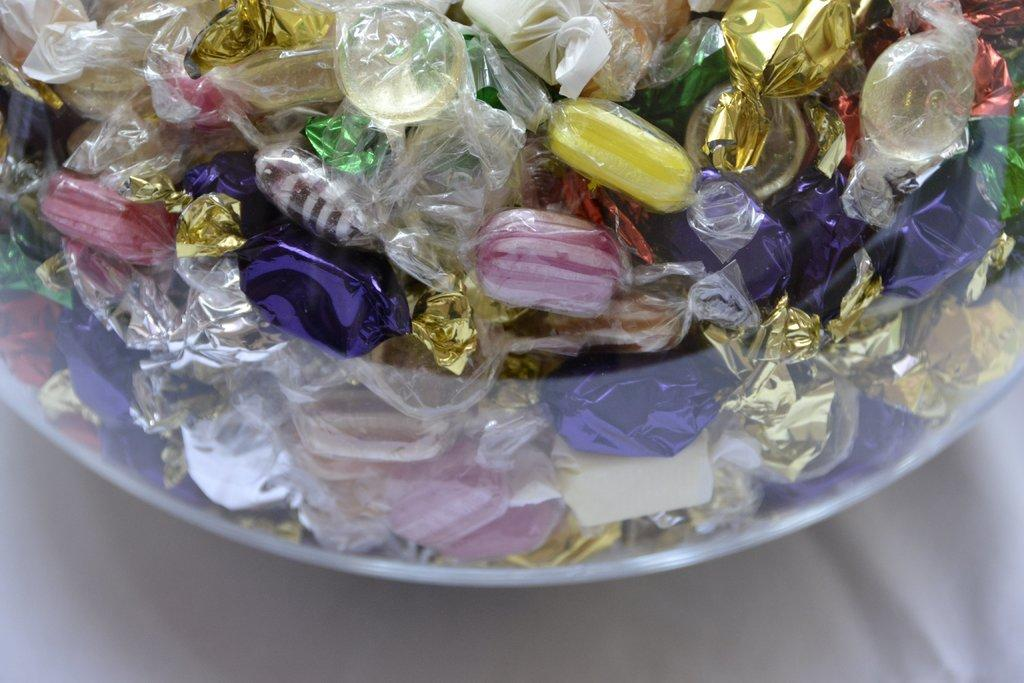What is the main object in the center of the image? There is a table in the center of the image. What is placed on the table? There is a bowl on the table. What is inside the bowl? The bowl contains different types of chocolates. What type of rings can be seen in the image? There are no rings present in the image; it features a table with a bowl of chocolates. What is the purpose of the pail in the image? There is no pail present in the image. 